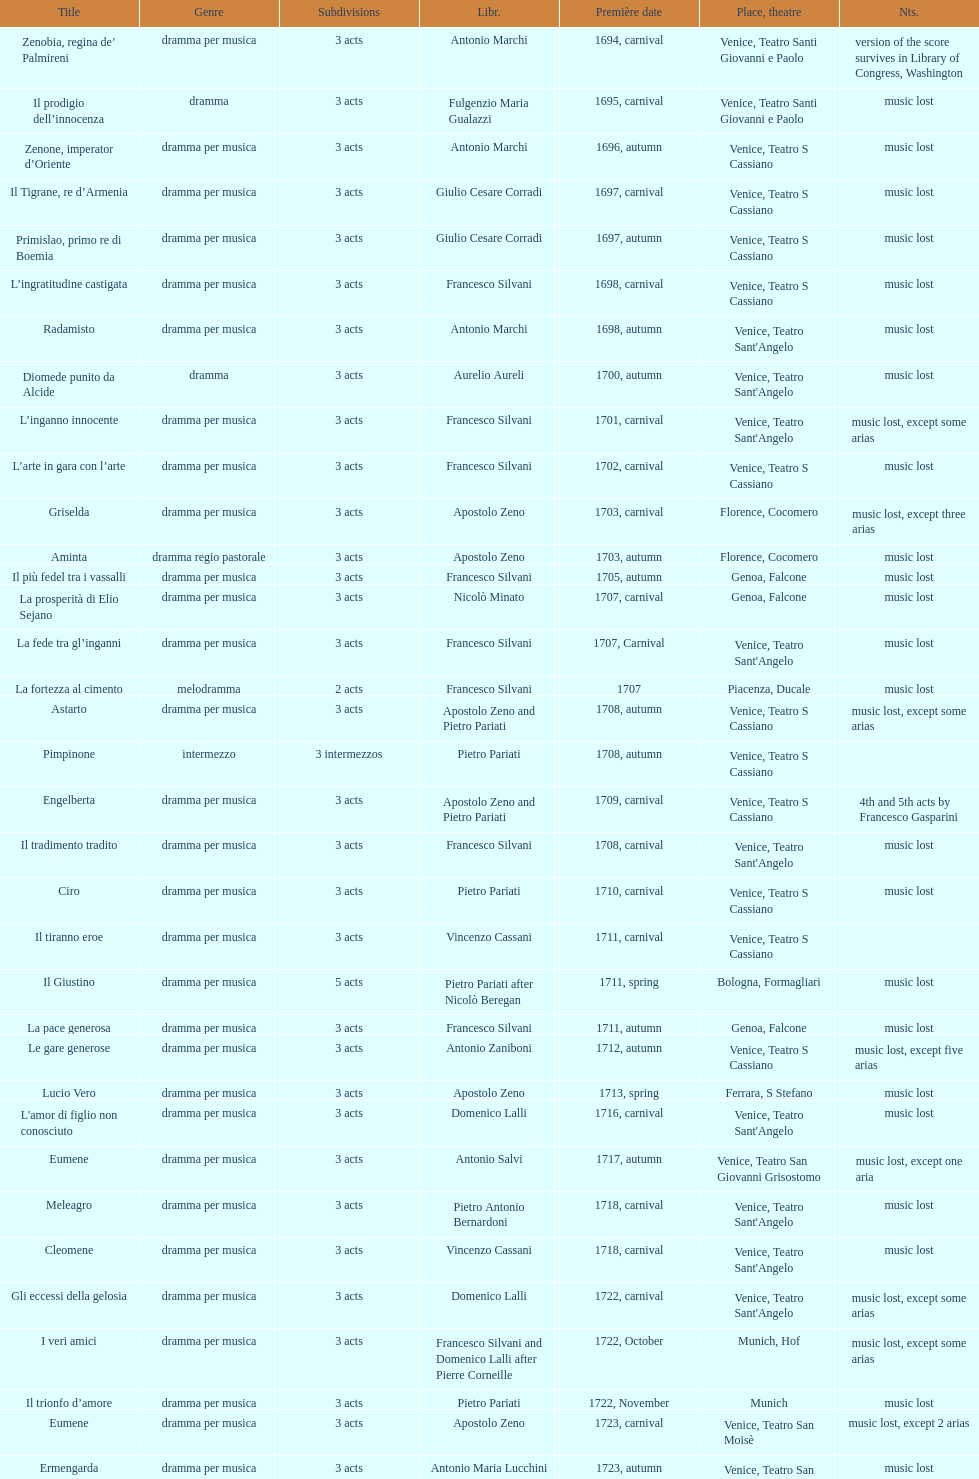Which opera has the most acts, la fortezza al cimento or astarto? Astarto. 